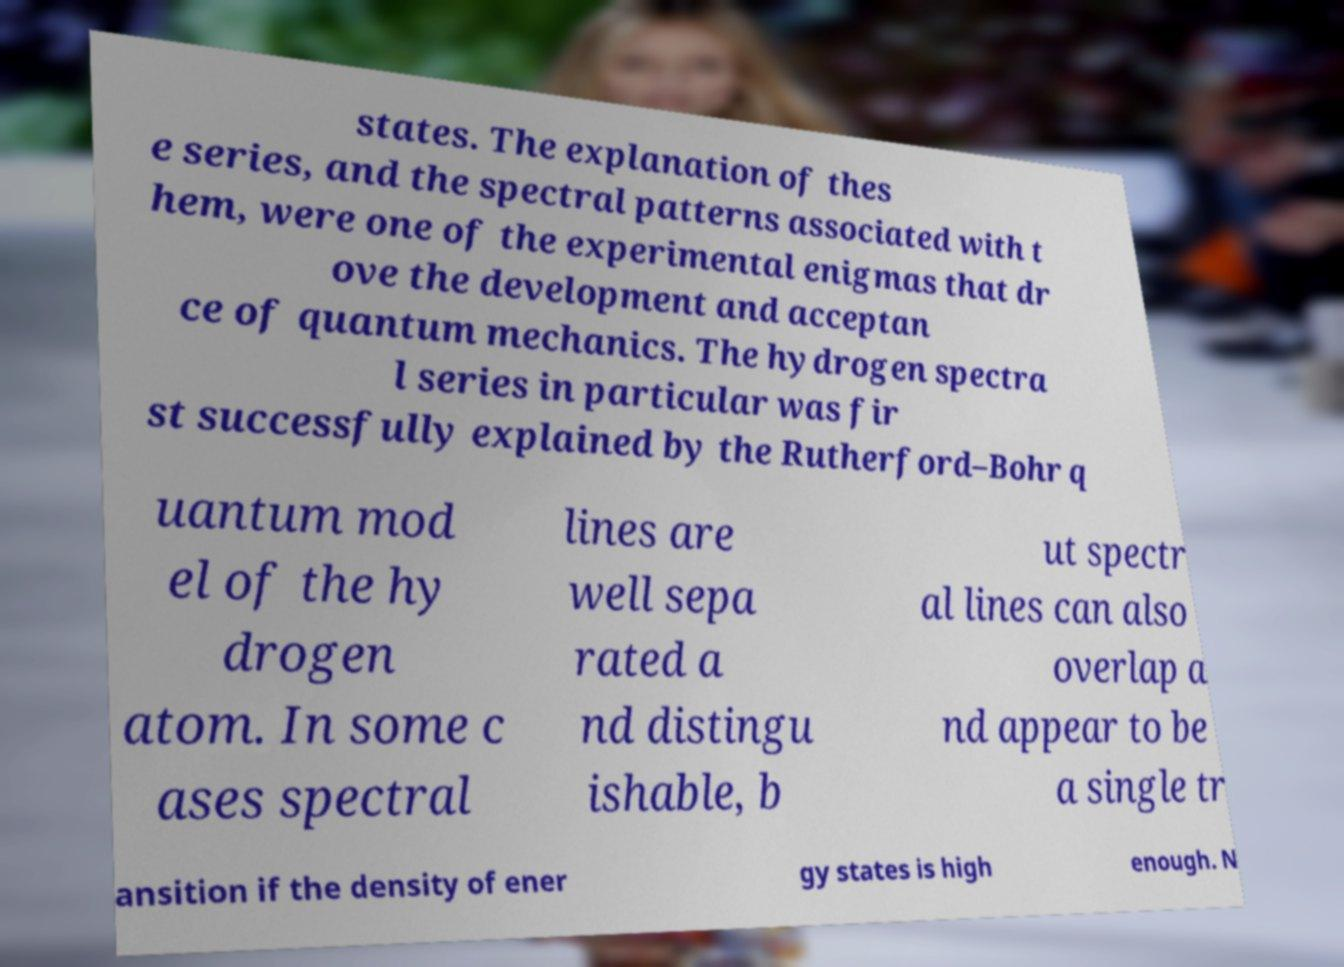There's text embedded in this image that I need extracted. Can you transcribe it verbatim? states. The explanation of thes e series, and the spectral patterns associated with t hem, were one of the experimental enigmas that dr ove the development and acceptan ce of quantum mechanics. The hydrogen spectra l series in particular was fir st successfully explained by the Rutherford–Bohr q uantum mod el of the hy drogen atom. In some c ases spectral lines are well sepa rated a nd distingu ishable, b ut spectr al lines can also overlap a nd appear to be a single tr ansition if the density of ener gy states is high enough. N 